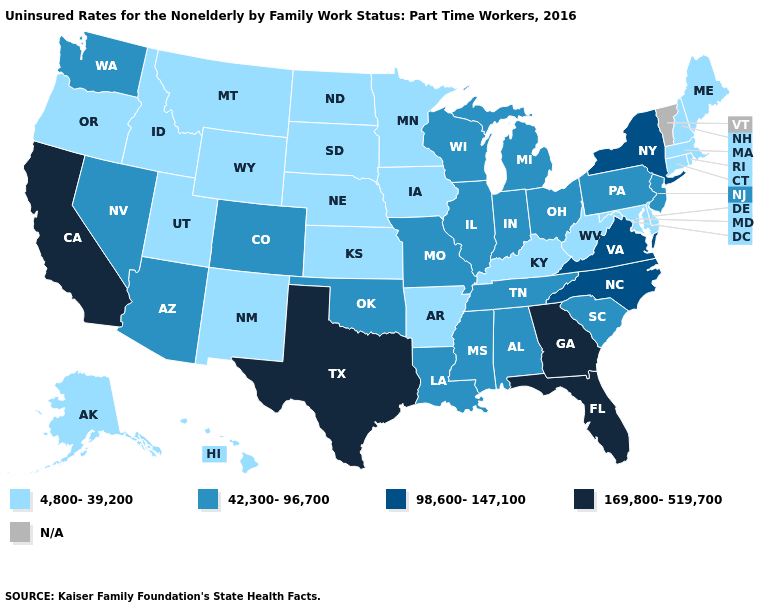Name the states that have a value in the range N/A?
Concise answer only. Vermont. What is the value of Michigan?
Concise answer only. 42,300-96,700. Does Massachusetts have the lowest value in the Northeast?
Quick response, please. Yes. Among the states that border Wisconsin , which have the lowest value?
Answer briefly. Iowa, Minnesota. Which states have the lowest value in the USA?
Write a very short answer. Alaska, Arkansas, Connecticut, Delaware, Hawaii, Idaho, Iowa, Kansas, Kentucky, Maine, Maryland, Massachusetts, Minnesota, Montana, Nebraska, New Hampshire, New Mexico, North Dakota, Oregon, Rhode Island, South Dakota, Utah, West Virginia, Wyoming. Among the states that border Virginia , does Maryland have the highest value?
Short answer required. No. What is the value of South Dakota?
Short answer required. 4,800-39,200. Does the first symbol in the legend represent the smallest category?
Answer briefly. Yes. Which states hav the highest value in the Northeast?
Answer briefly. New York. Does Mississippi have the lowest value in the South?
Keep it brief. No. What is the value of Oklahoma?
Quick response, please. 42,300-96,700. What is the value of North Carolina?
Concise answer only. 98,600-147,100. What is the value of Alaska?
Write a very short answer. 4,800-39,200. Among the states that border Georgia , does Florida have the lowest value?
Short answer required. No. Name the states that have a value in the range 42,300-96,700?
Quick response, please. Alabama, Arizona, Colorado, Illinois, Indiana, Louisiana, Michigan, Mississippi, Missouri, Nevada, New Jersey, Ohio, Oklahoma, Pennsylvania, South Carolina, Tennessee, Washington, Wisconsin. 